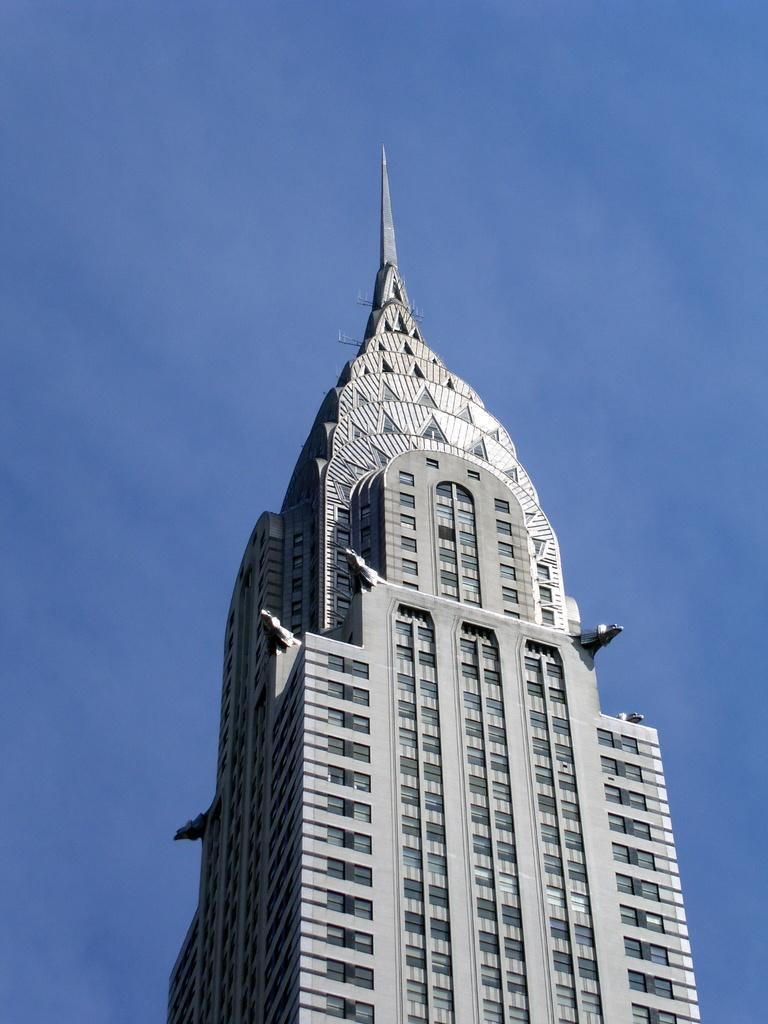What type of structure is present in the image? There is a building in the picture. How would you describe the sky in the image? The sky is blue and cloudy. What type of belief system is depicted in the image? There is no indication of a belief system in the image; it features a building and a blue, cloudy sky. 